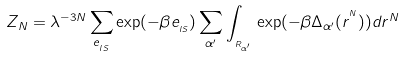Convert formula to latex. <formula><loc_0><loc_0><loc_500><loc_500>Z _ { N } = \lambda ^ { - 3 N } \sum _ { e _ { _ { I S } } } \exp ( - \beta e _ { _ { I S } } ) \sum _ { \alpha ^ { \prime } } \int _ { _ { _ { R _ { \alpha ^ { \prime } } } } } \exp ( - \beta \Delta _ { \alpha ^ { \prime } } ( { r } ^ { ^ { N } } ) ) d { r } ^ { N }</formula> 